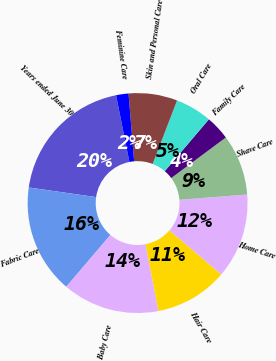<chart> <loc_0><loc_0><loc_500><loc_500><pie_chart><fcel>Years ended June 30<fcel>Fabric Care<fcel>Baby Care<fcel>Hair Care<fcel>Home Care<fcel>Shave Care<fcel>Family Care<fcel>Oral Care<fcel>Skin and Personal Care<fcel>Feminine Care<nl><fcel>19.6%<fcel>16.04%<fcel>14.27%<fcel>10.71%<fcel>12.49%<fcel>8.93%<fcel>3.6%<fcel>5.38%<fcel>7.16%<fcel>1.82%<nl></chart> 